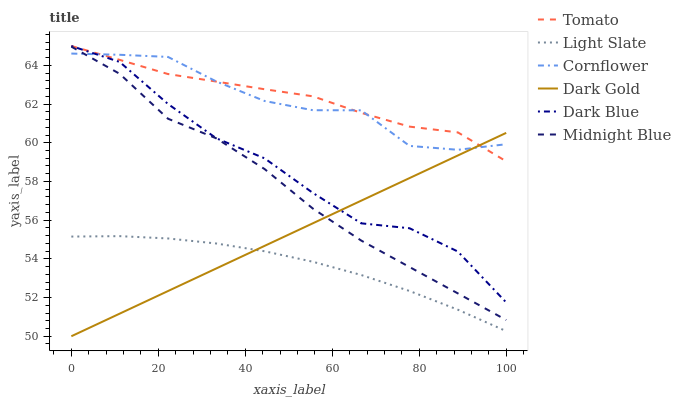Does Light Slate have the minimum area under the curve?
Answer yes or no. Yes. Does Tomato have the maximum area under the curve?
Answer yes or no. Yes. Does Cornflower have the minimum area under the curve?
Answer yes or no. No. Does Cornflower have the maximum area under the curve?
Answer yes or no. No. Is Dark Gold the smoothest?
Answer yes or no. Yes. Is Dark Blue the roughest?
Answer yes or no. Yes. Is Cornflower the smoothest?
Answer yes or no. No. Is Cornflower the roughest?
Answer yes or no. No. Does Midnight Blue have the lowest value?
Answer yes or no. No. Does Dark Blue have the highest value?
Answer yes or no. Yes. Does Cornflower have the highest value?
Answer yes or no. No. Is Midnight Blue less than Dark Blue?
Answer yes or no. Yes. Is Midnight Blue greater than Light Slate?
Answer yes or no. Yes. Does Dark Blue intersect Tomato?
Answer yes or no. Yes. Is Dark Blue less than Tomato?
Answer yes or no. No. Is Dark Blue greater than Tomato?
Answer yes or no. No. Does Midnight Blue intersect Dark Blue?
Answer yes or no. No. 